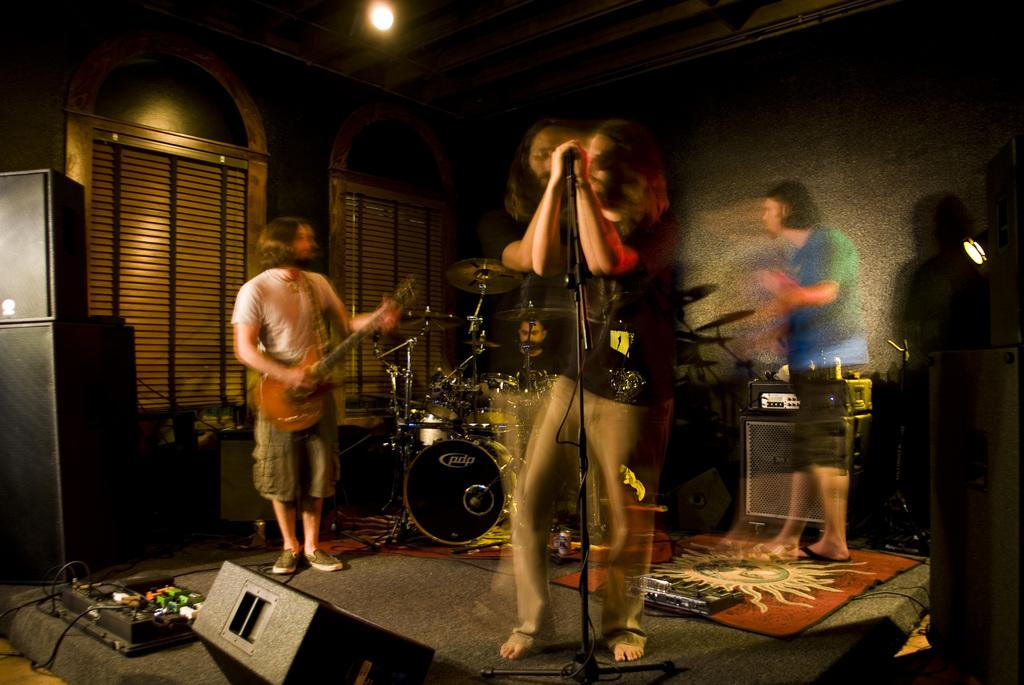What are the people in the image doing? The people in the image are playing musical instruments. What types of musical instruments are being played? The people are playing different types of musical instruments. What can be seen in the background of the image? There is a wall and a window in the image. What verse is being recited by the tiger in the image? There is no tiger present in the image, and therefore no verse being recited. 